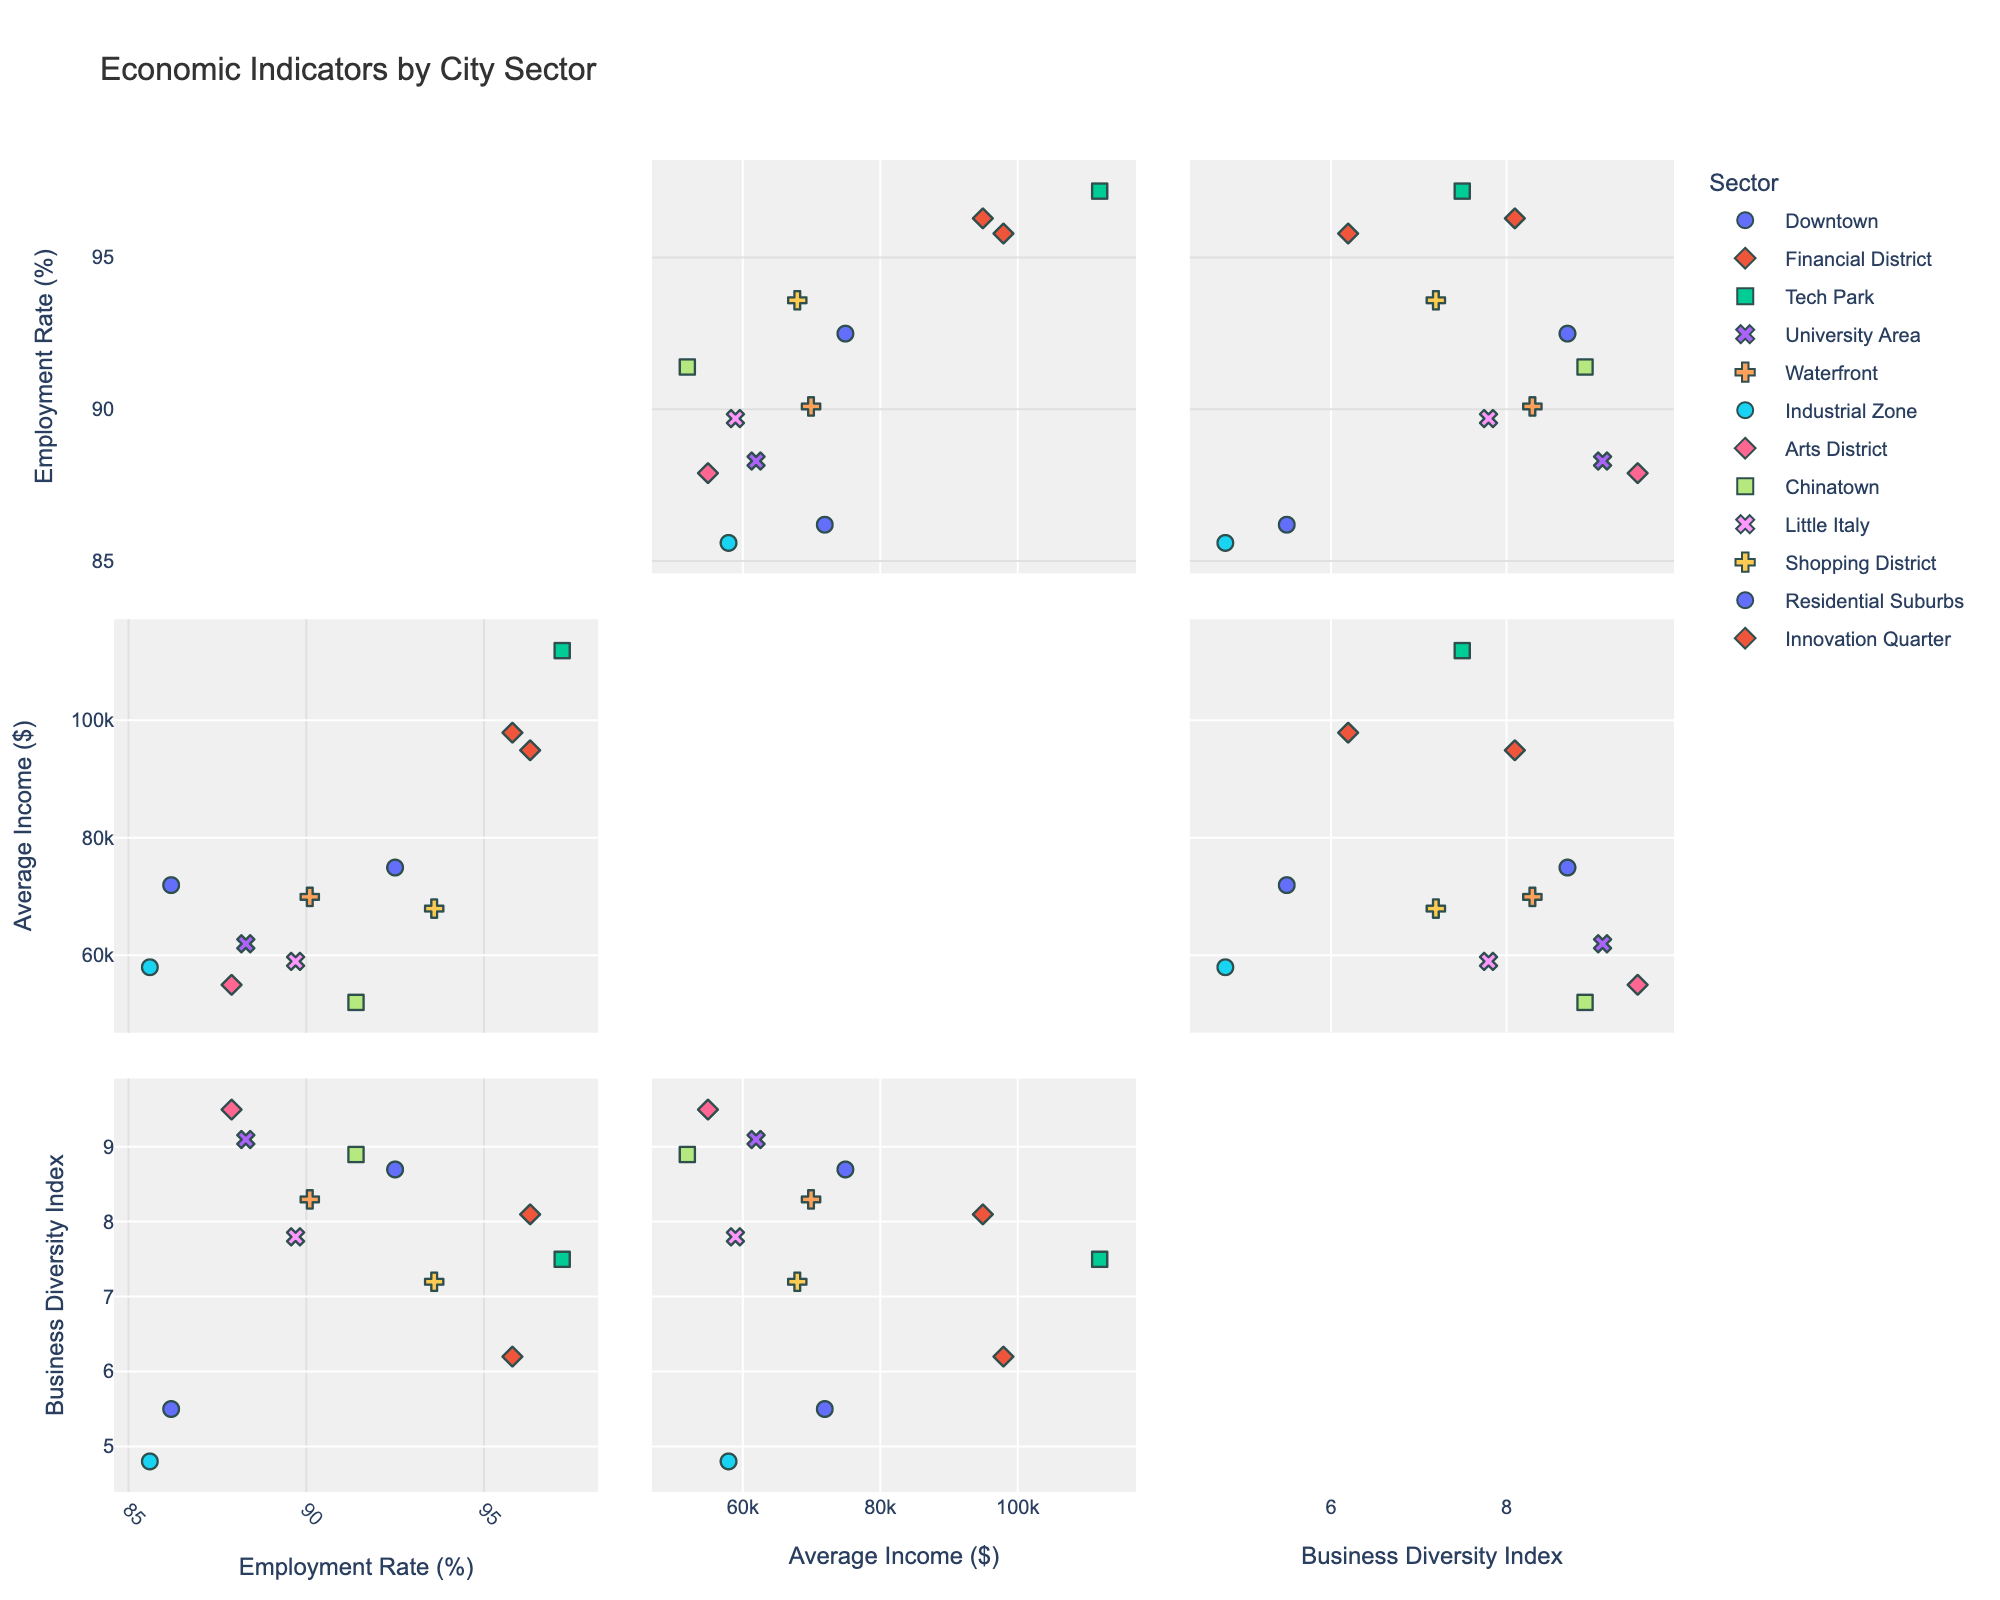What is the employment rate in the Financial District? Look for the data point labeled "Financial District" and find its value on the "Employment Rate" axis.
Answer: 95.8 Which sector has the highest average income? Identify the data point with the highest value on the "Average Income" axis and note the corresponding sector label.
Answer: Tech Park Compare the business diversity of Downtown and Innovation Quarter. Which one has a higher value? Find the data points labeled "Downtown" and "Innovation Quarter" on the "Business Diversity" axis and compare their values.
Answer: Downtown Calculate the average employment rate for sectors with an average income above $80,000. Identify the sectors where the "Average Income" value exceeds $80,000, then average their "Employment Rate" values. Sectors: Financial District (95.8), Tech Park (97.2), and Innovation Quarter (96.3). Average = (95.8 + 97.2 + 96.3)/3
Answer: 96.43 Is there a correlation between employment rate and average income? Look at the scatter plot of "Employment Rate" vs. "Average Income." Determine whether data points follow a discernible trend, such as increasing together or independently.
Answer: Positive correlation Which sector has the lowest business diversity? Identify the data point with the lowest value on the "Business Diversity" axis and note the corresponding sector label.
Answer: Industrial Zone Compare the employment rates between Tech Park and University Area. Which one is higher, and by how much? Find the data points labeled "Tech Park" and "University Area" on the "Employment Rate" axis. Subtract the smaller value from the larger one to find the difference.
Answer: Tech Park is higher by 8.9 (97.2 - 88.3) What is the business diversity index of the Arts District? Look for the data point labeled "Arts District" and find its value on the "Business Diversity" axis.
Answer: 9.5 Which sectors have an average income below $60,000? Identify the data points on the "Average Income" axis with values below $60,000 and note their sector labels.
Answer: Arts District, Chinatown, and Industrial Zone Determine the sector with the highest employment rate and the sector with the highest business diversity. Are they the same? Find the sectors with the highest values on the "Employment Rate" and "Business Diversity" axes separately.
Answer: No, highest employment rate: Tech Park, highest business diversity: Arts District 